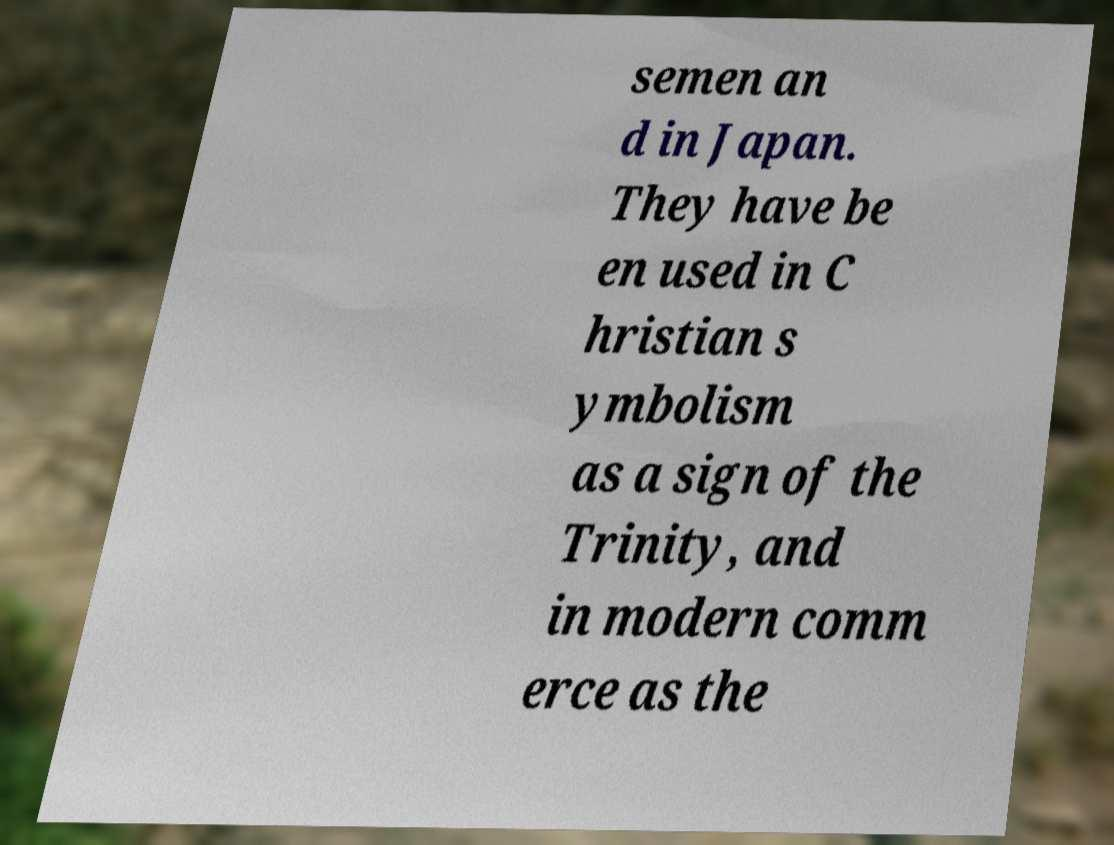Could you extract and type out the text from this image? semen an d in Japan. They have be en used in C hristian s ymbolism as a sign of the Trinity, and in modern comm erce as the 